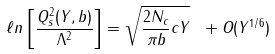<formula> <loc_0><loc_0><loc_500><loc_500>\ell n \left [ { \frac { Q _ { s } ^ { 2 } ( Y , b ) } { \Lambda ^ { 2 } } } \right ] = { \sqrt { { \frac { 2 N _ { c } } { \pi b } } c Y } } \ + O ( Y ^ { 1 / 6 } )</formula> 